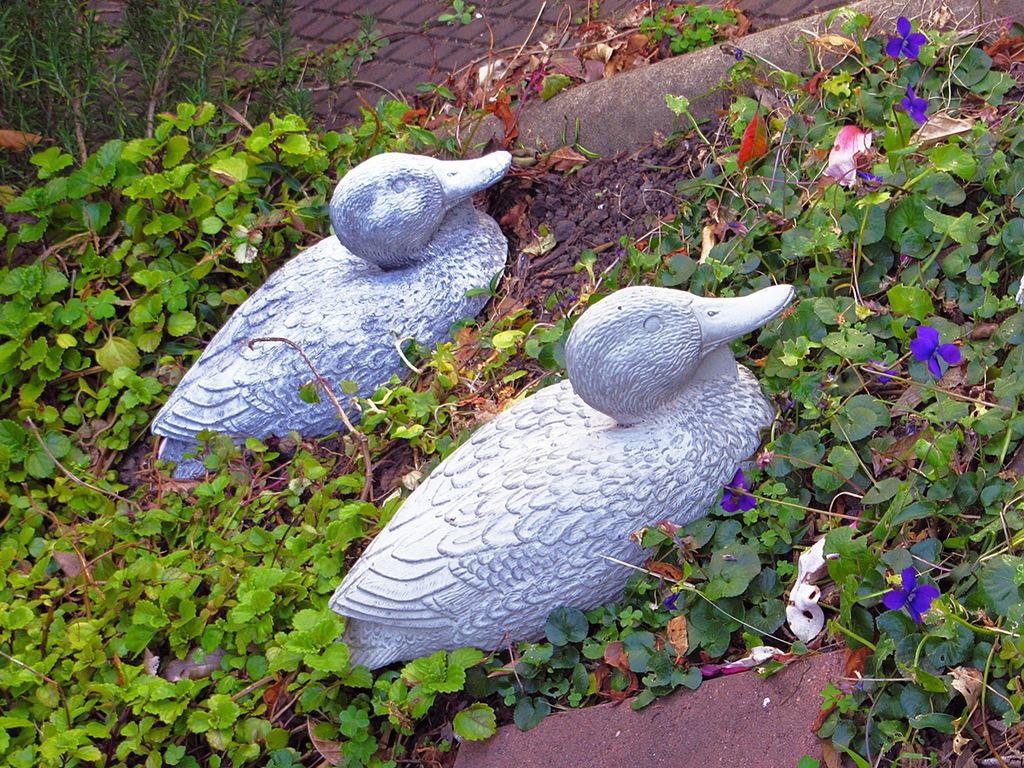What can be seen on the ground in the image? There are two sculptures on the ground. What is visible in the background of the image? There are plants in the background of the image. What type of sponge is being used to clean the sculptures in the image? There is no sponge present in the image, and the sculptures are not being cleaned. 